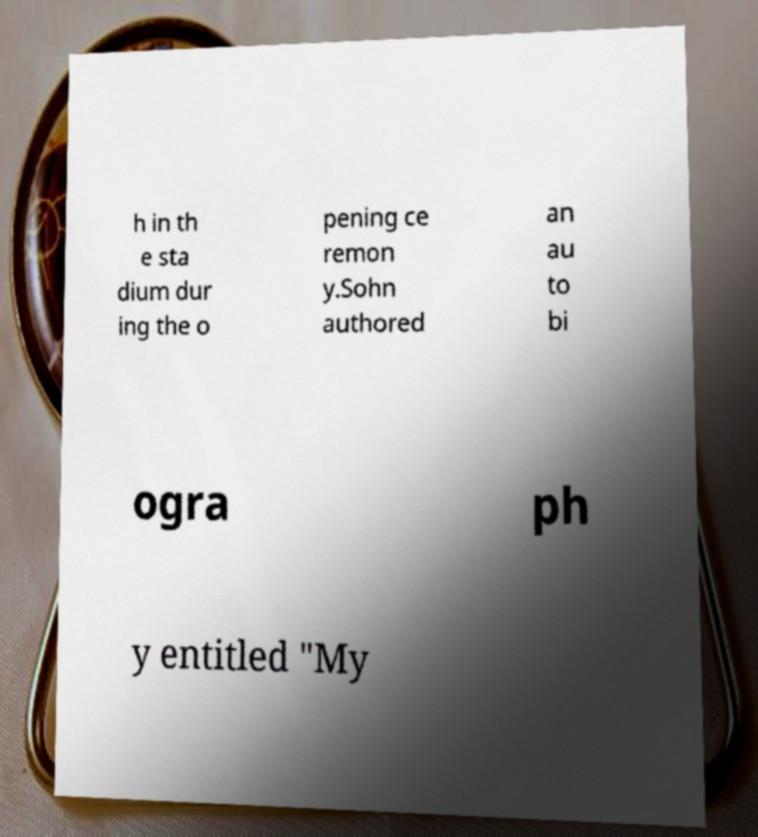There's text embedded in this image that I need extracted. Can you transcribe it verbatim? h in th e sta dium dur ing the o pening ce remon y.Sohn authored an au to bi ogra ph y entitled "My 